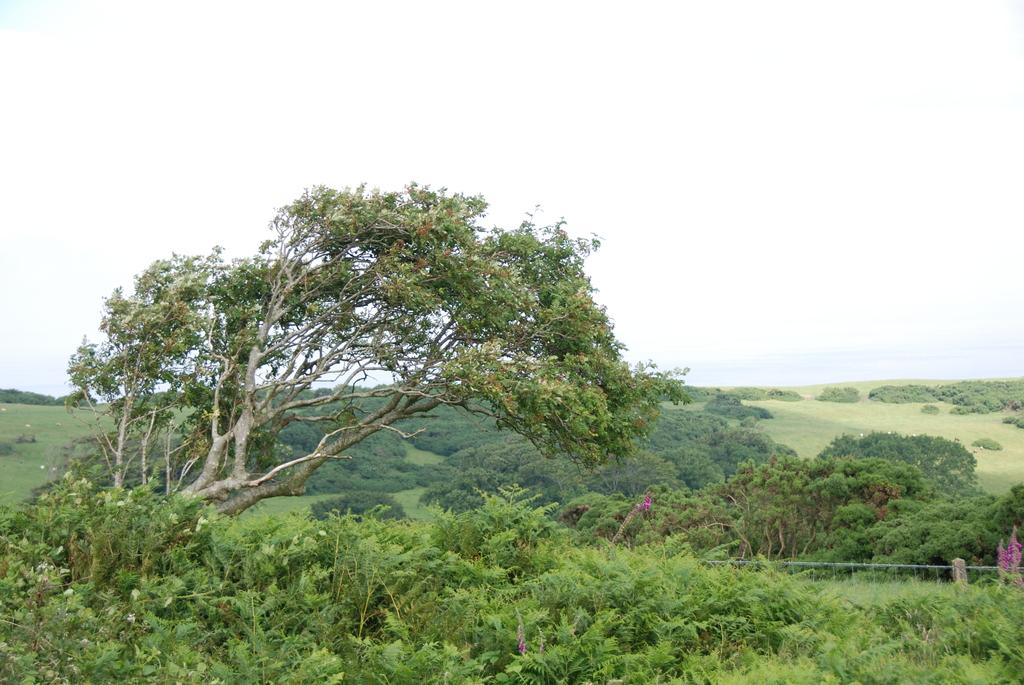What type of vegetation can be seen in the image? There are trees in the image. What is the condition of the sky in the image? The sky is cloudy at the top of the image. What type of string is being used by the carpenter in the image? There is no carpenter or string present in the image; it only features trees and a cloudy sky. 